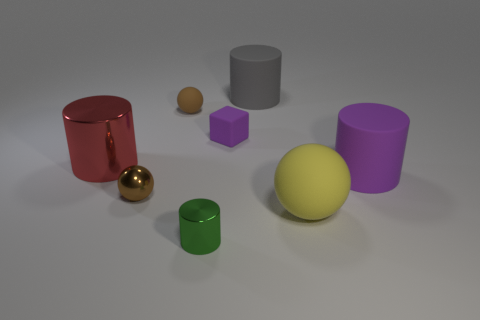Is the small rubber ball the same color as the small shiny sphere?
Give a very brief answer. Yes. What number of objects are cylinders on the right side of the yellow rubber thing or green cylinders?
Your answer should be compact. 2. What color is the rubber cylinder that is behind the large matte cylinder in front of the purple rubber object that is to the left of the gray matte object?
Provide a succinct answer. Gray. There is a cube that is the same material as the yellow object; what color is it?
Offer a terse response. Purple. What number of big cyan things are the same material as the small purple cube?
Your answer should be compact. 0. Do the metallic cylinder that is behind the metallic ball and the small green object have the same size?
Offer a terse response. No. What is the color of the metallic cylinder that is the same size as the block?
Your answer should be compact. Green. There is a tiny brown shiny sphere; how many small shiny spheres are in front of it?
Your answer should be very brief. 0. Are there any small metal cylinders?
Offer a terse response. Yes. What size is the ball that is behind the big cylinder left of the small thing in front of the large yellow rubber sphere?
Ensure brevity in your answer.  Small. 